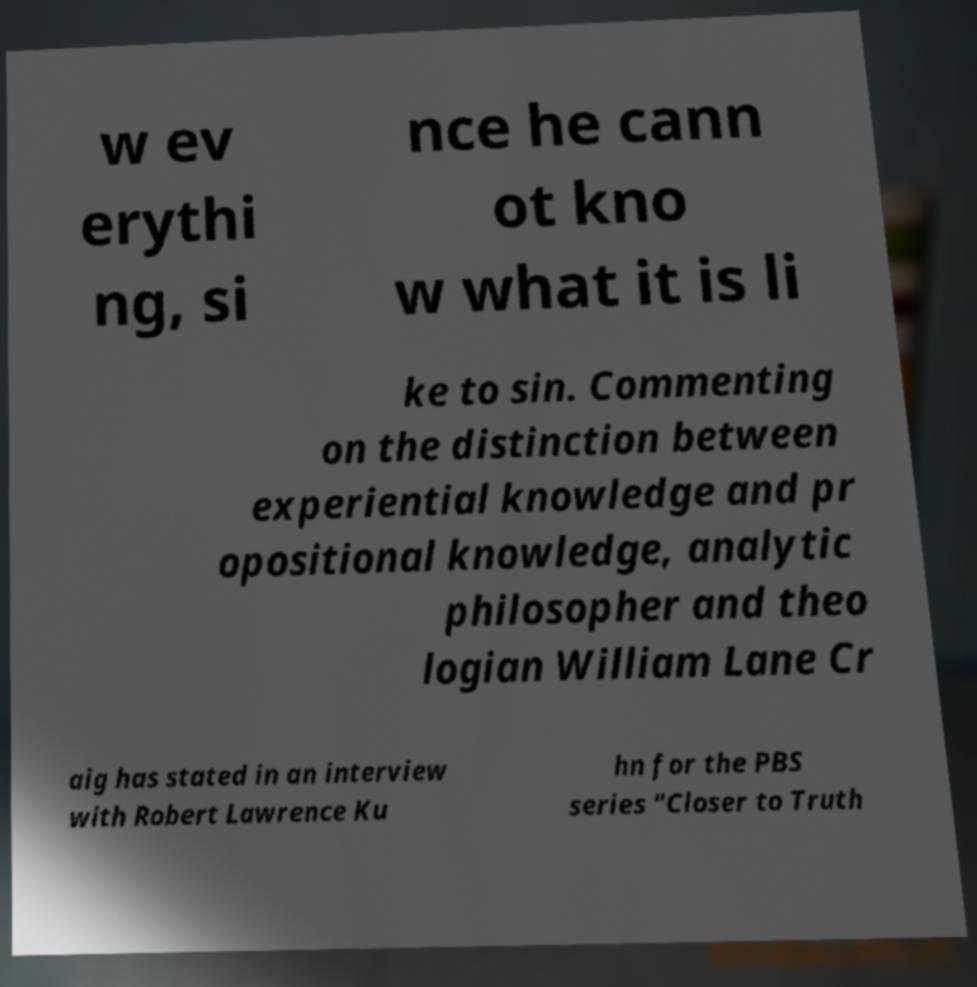What messages or text are displayed in this image? I need them in a readable, typed format. w ev erythi ng, si nce he cann ot kno w what it is li ke to sin. Commenting on the distinction between experiential knowledge and pr opositional knowledge, analytic philosopher and theo logian William Lane Cr aig has stated in an interview with Robert Lawrence Ku hn for the PBS series "Closer to Truth 